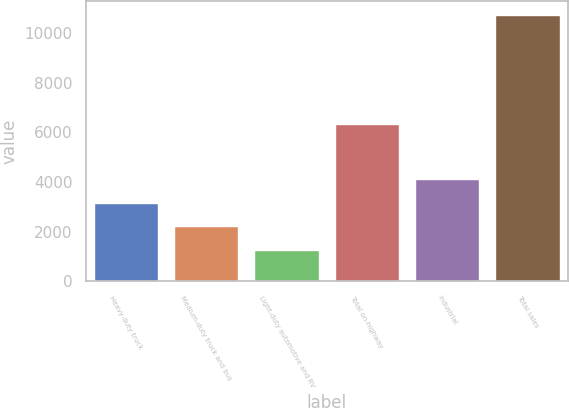Convert chart to OTSL. <chart><loc_0><loc_0><loc_500><loc_500><bar_chart><fcel>Heavy-duty truck<fcel>Medium-duty truck and bus<fcel>Light-duty automotive and RV<fcel>Total on-highway<fcel>Industrial<fcel>Total sales<nl><fcel>3169.8<fcel>2224.4<fcel>1279<fcel>6334<fcel>4115.2<fcel>10733<nl></chart> 